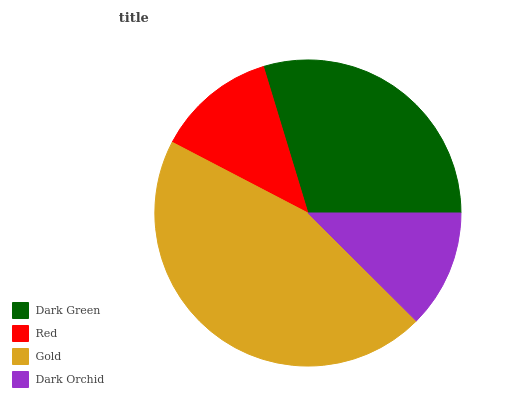Is Dark Orchid the minimum?
Answer yes or no. Yes. Is Gold the maximum?
Answer yes or no. Yes. Is Red the minimum?
Answer yes or no. No. Is Red the maximum?
Answer yes or no. No. Is Dark Green greater than Red?
Answer yes or no. Yes. Is Red less than Dark Green?
Answer yes or no. Yes. Is Red greater than Dark Green?
Answer yes or no. No. Is Dark Green less than Red?
Answer yes or no. No. Is Dark Green the high median?
Answer yes or no. Yes. Is Red the low median?
Answer yes or no. Yes. Is Dark Orchid the high median?
Answer yes or no. No. Is Gold the low median?
Answer yes or no. No. 